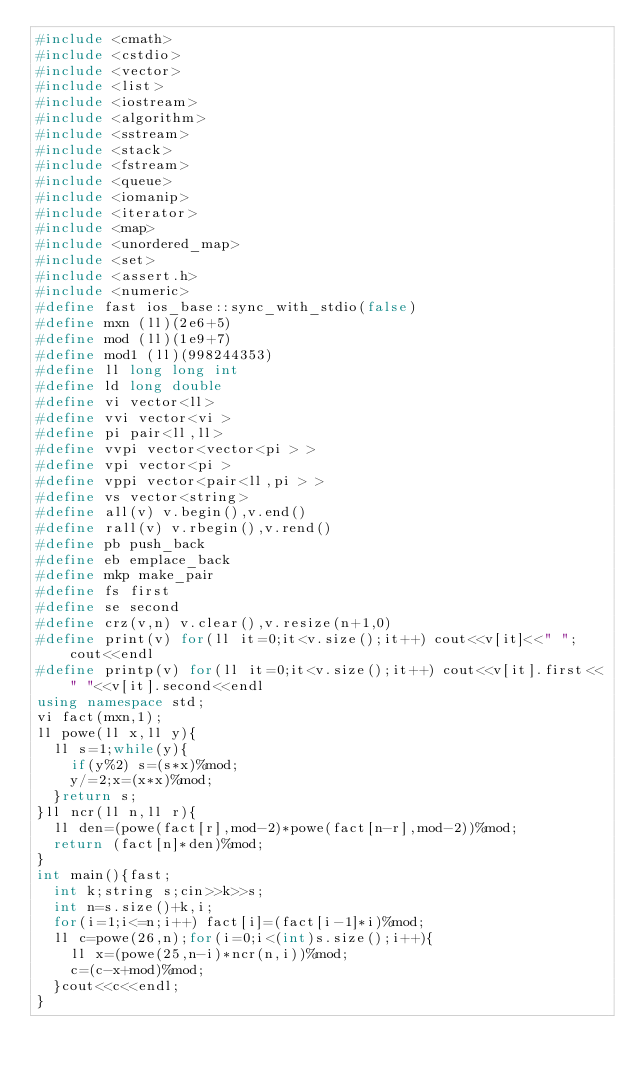Convert code to text. <code><loc_0><loc_0><loc_500><loc_500><_C++_>#include <cmath>
#include <cstdio>
#include <vector>
#include <list>
#include <iostream>
#include <algorithm>
#include <sstream>
#include <stack>
#include <fstream>
#include <queue>
#include <iomanip>
#include <iterator>
#include <map>
#include <unordered_map>
#include <set>
#include <assert.h>
#include <numeric>
#define fast ios_base::sync_with_stdio(false)
#define mxn (ll)(2e6+5)
#define mod (ll)(1e9+7)
#define mod1 (ll)(998244353)
#define ll long long int
#define ld long double
#define vi vector<ll>
#define vvi vector<vi >
#define pi pair<ll,ll>
#define vvpi vector<vector<pi > >
#define vpi vector<pi >
#define vppi vector<pair<ll,pi > >
#define vs vector<string>
#define all(v) v.begin(),v.end()
#define rall(v) v.rbegin(),v.rend()
#define pb push_back
#define eb emplace_back
#define mkp make_pair
#define fs first
#define se second
#define crz(v,n) v.clear(),v.resize(n+1,0)
#define print(v) for(ll it=0;it<v.size();it++) cout<<v[it]<<" ";cout<<endl
#define printp(v) for(ll it=0;it<v.size();it++) cout<<v[it].first<<" "<<v[it].second<<endl
using namespace std;
vi fact(mxn,1);
ll powe(ll x,ll y){
	ll s=1;while(y){
		if(y%2) s=(s*x)%mod;
		y/=2;x=(x*x)%mod;
	}return s;
}ll ncr(ll n,ll r){
	ll den=(powe(fact[r],mod-2)*powe(fact[n-r],mod-2))%mod;
	return (fact[n]*den)%mod;
}
int main(){fast;
	int k;string s;cin>>k>>s;
	int n=s.size()+k,i;
	for(i=1;i<=n;i++) fact[i]=(fact[i-1]*i)%mod;
	ll c=powe(26,n);for(i=0;i<(int)s.size();i++){
		ll x=(powe(25,n-i)*ncr(n,i))%mod;
		c=(c-x+mod)%mod;
	}cout<<c<<endl;
}
</code> 